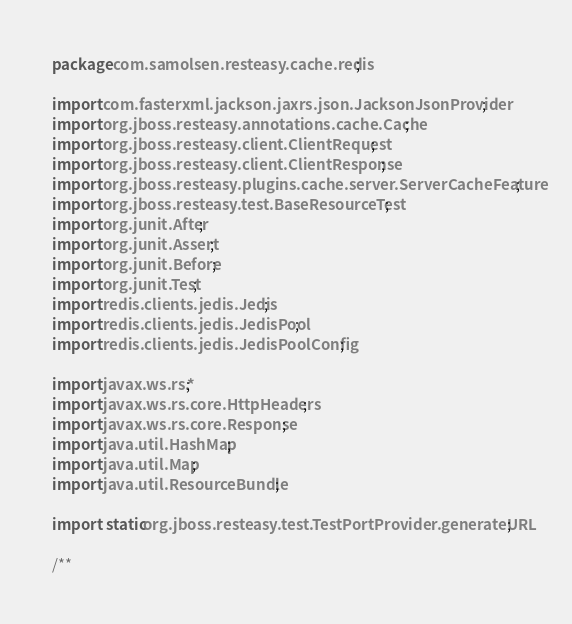Convert code to text. <code><loc_0><loc_0><loc_500><loc_500><_Java_>package com.samolsen.resteasy.cache.redis;

import com.fasterxml.jackson.jaxrs.json.JacksonJsonProvider;
import org.jboss.resteasy.annotations.cache.Cache;
import org.jboss.resteasy.client.ClientRequest;
import org.jboss.resteasy.client.ClientResponse;
import org.jboss.resteasy.plugins.cache.server.ServerCacheFeature;
import org.jboss.resteasy.test.BaseResourceTest;
import org.junit.After;
import org.junit.Assert;
import org.junit.Before;
import org.junit.Test;
import redis.clients.jedis.Jedis;
import redis.clients.jedis.JedisPool;
import redis.clients.jedis.JedisPoolConfig;

import javax.ws.rs.*;
import javax.ws.rs.core.HttpHeaders;
import javax.ws.rs.core.Response;
import java.util.HashMap;
import java.util.Map;
import java.util.ResourceBundle;

import static org.jboss.resteasy.test.TestPortProvider.generateURL;

/**</code> 